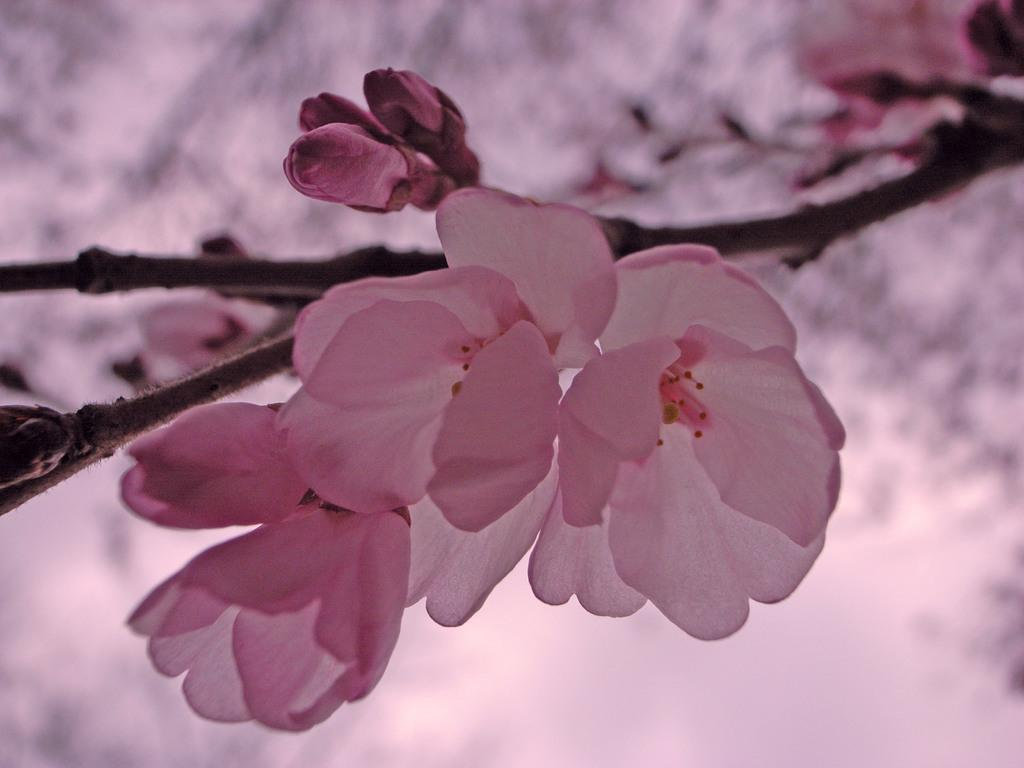What type of flowers can be seen on the tree branch in the image? There are pink flowers on a tree branch in the image. How would you describe the background of the image? The background of the image appears blurry. What type of canvas is the doctor using to paint the fifth flower in the image? There is no canvas, doctor, or painting activity present in the image. 